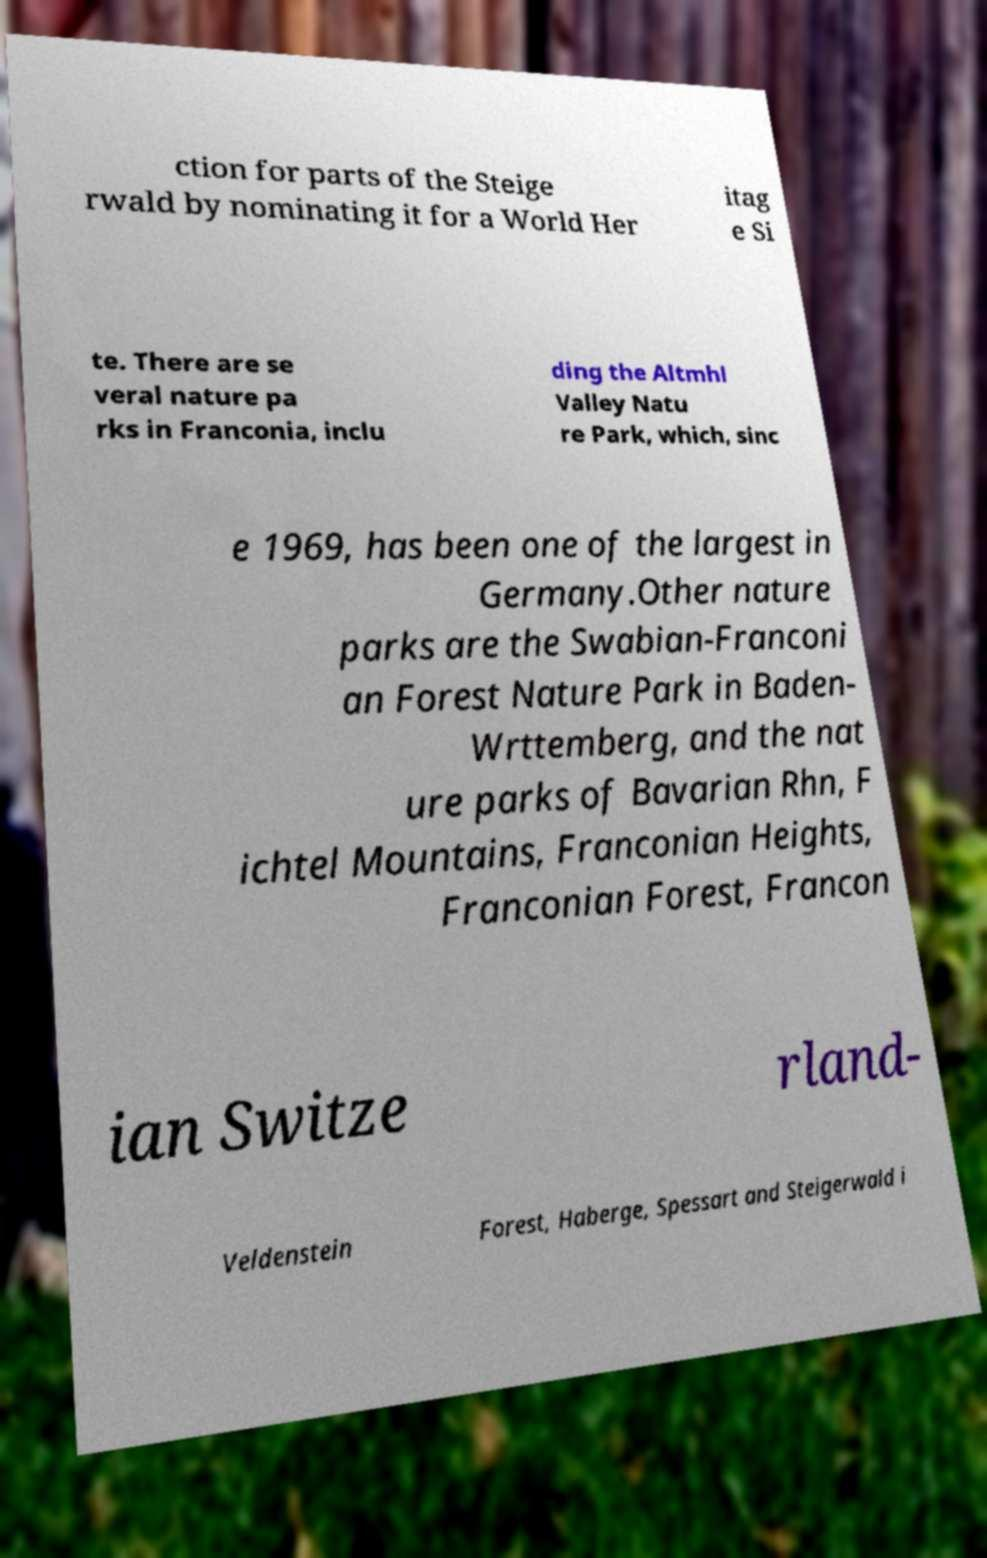Could you extract and type out the text from this image? ction for parts of the Steige rwald by nominating it for a World Her itag e Si te. There are se veral nature pa rks in Franconia, inclu ding the Altmhl Valley Natu re Park, which, sinc e 1969, has been one of the largest in Germany.Other nature parks are the Swabian-Franconi an Forest Nature Park in Baden- Wrttemberg, and the nat ure parks of Bavarian Rhn, F ichtel Mountains, Franconian Heights, Franconian Forest, Francon ian Switze rland- Veldenstein Forest, Haberge, Spessart and Steigerwald i 